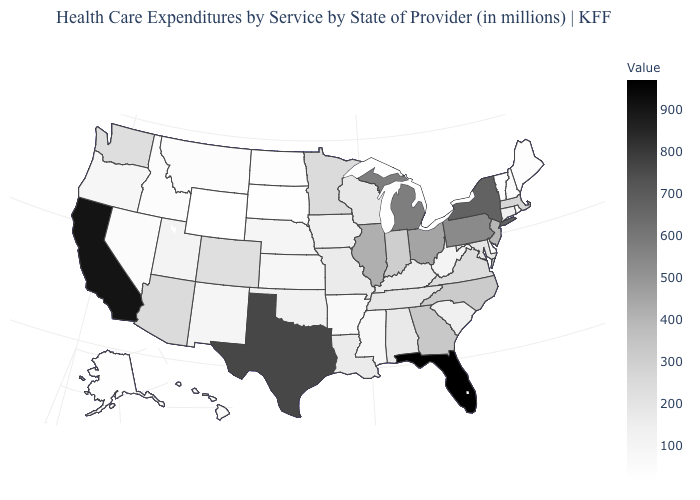Among the states that border New York , which have the lowest value?
Be succinct. Vermont. Among the states that border Delaware , does Maryland have the lowest value?
Give a very brief answer. Yes. Which states have the lowest value in the USA?
Keep it brief. Vermont, Wyoming. Does Minnesota have a higher value than Illinois?
Concise answer only. No. Which states have the highest value in the USA?
Be succinct. Florida. Among the states that border Montana , which have the lowest value?
Give a very brief answer. Wyoming. Is the legend a continuous bar?
Answer briefly. Yes. Which states hav the highest value in the Northeast?
Write a very short answer. New York. Does Oregon have the lowest value in the USA?
Quick response, please. No. 